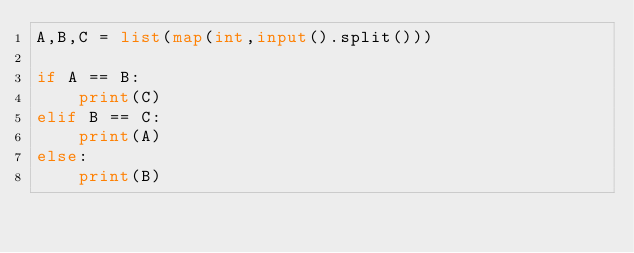<code> <loc_0><loc_0><loc_500><loc_500><_Python_>A,B,C = list(map(int,input().split()))

if A == B:
    print(C)
elif B == C:
    print(A)
else:
    print(B)</code> 